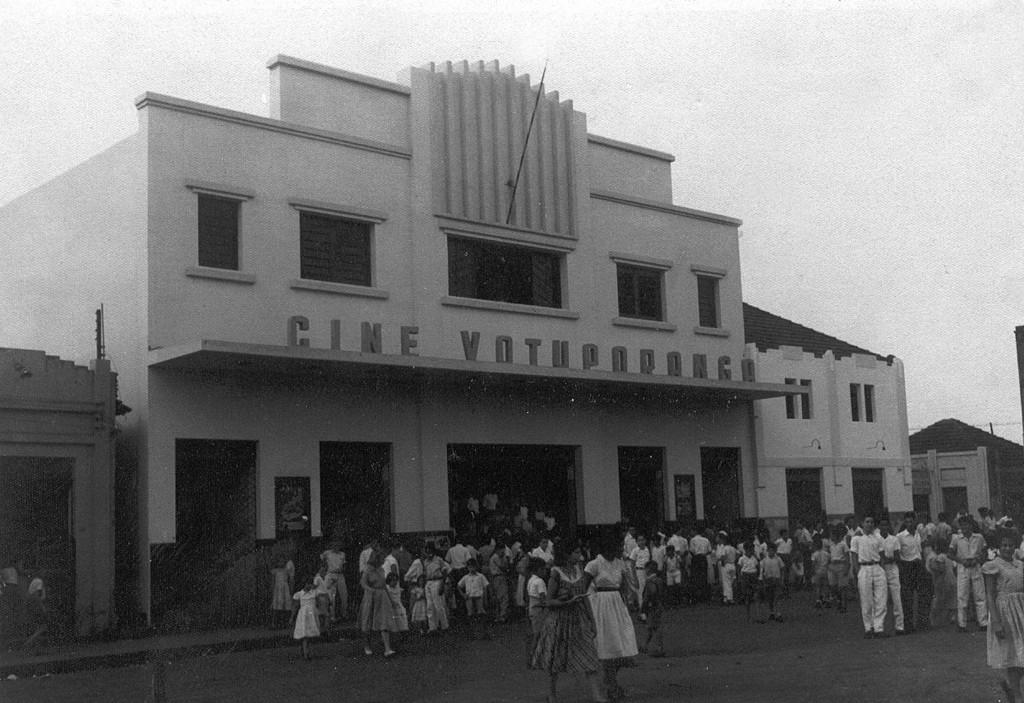What is located in the center of the image? There are buildings in the center of the image. What are the children doing at the bottom of the image? Some children are walking, and others are standing at the bottom of the image. What can be seen at the top of the image? The sky is visible at the top of the image. What is the price of the park in the image? There is no park present in the image, so it is not possible to determine its price. 